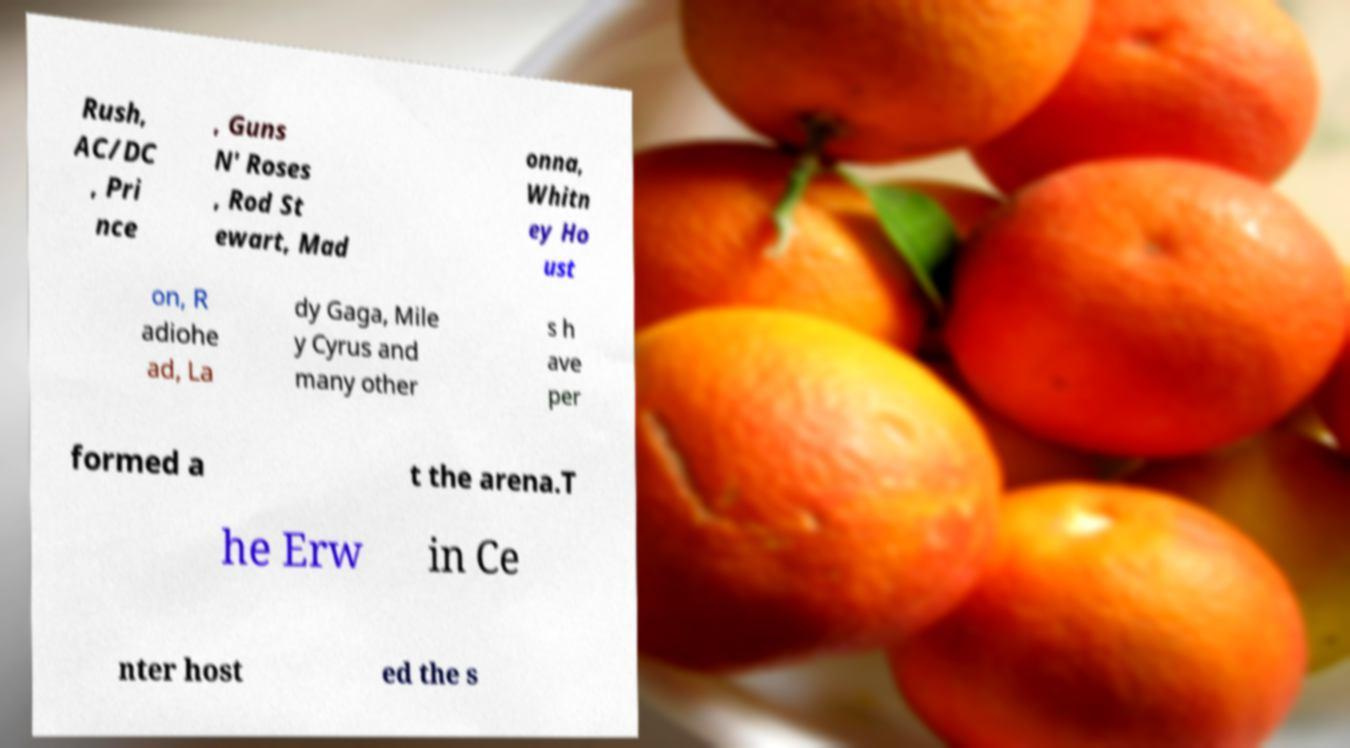Can you read and provide the text displayed in the image?This photo seems to have some interesting text. Can you extract and type it out for me? Rush, AC/DC , Pri nce , Guns N' Roses , Rod St ewart, Mad onna, Whitn ey Ho ust on, R adiohe ad, La dy Gaga, Mile y Cyrus and many other s h ave per formed a t the arena.T he Erw in Ce nter host ed the s 